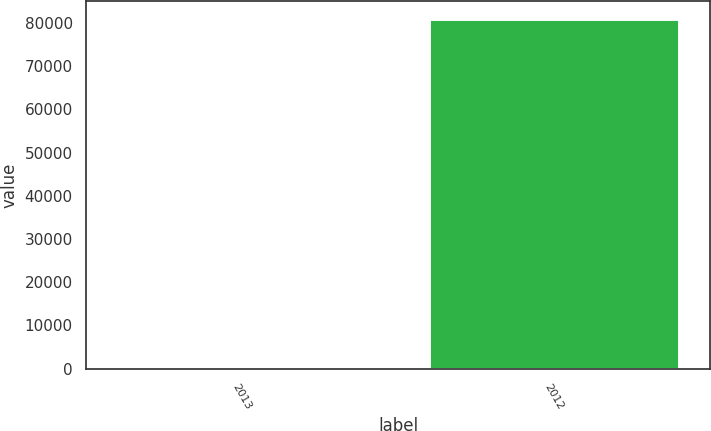<chart> <loc_0><loc_0><loc_500><loc_500><bar_chart><fcel>2013<fcel>2012<nl><fcel>484<fcel>80974<nl></chart> 